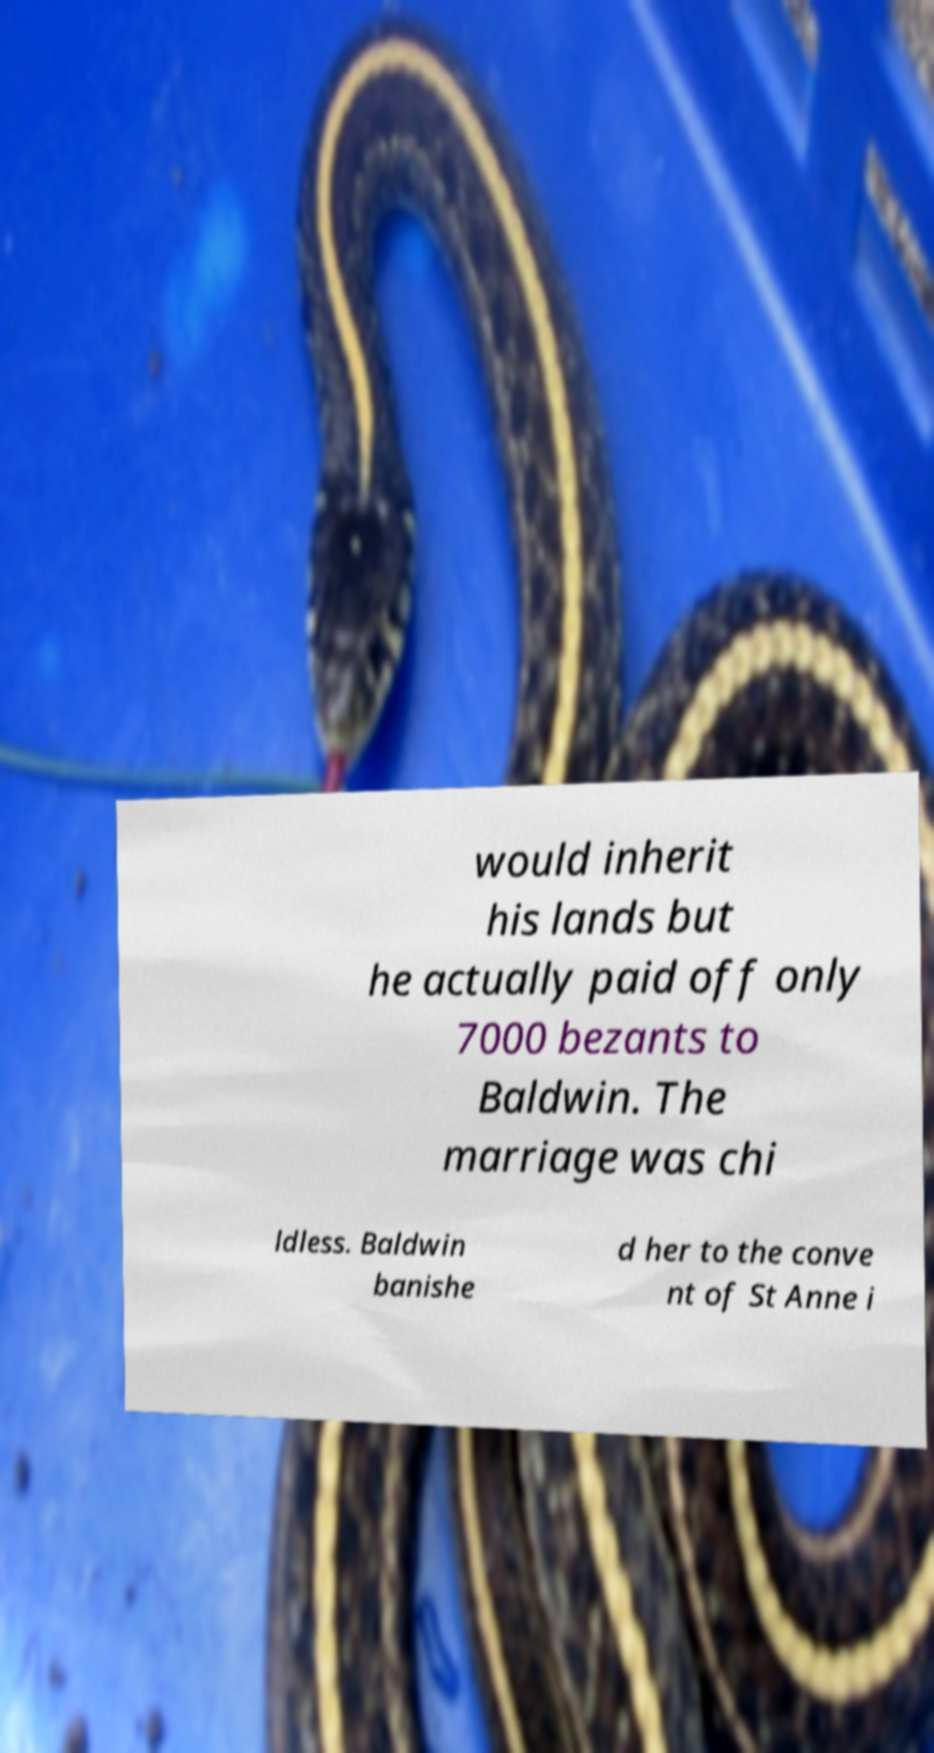What messages or text are displayed in this image? I need them in a readable, typed format. would inherit his lands but he actually paid off only 7000 bezants to Baldwin. The marriage was chi ldless. Baldwin banishe d her to the conve nt of St Anne i 